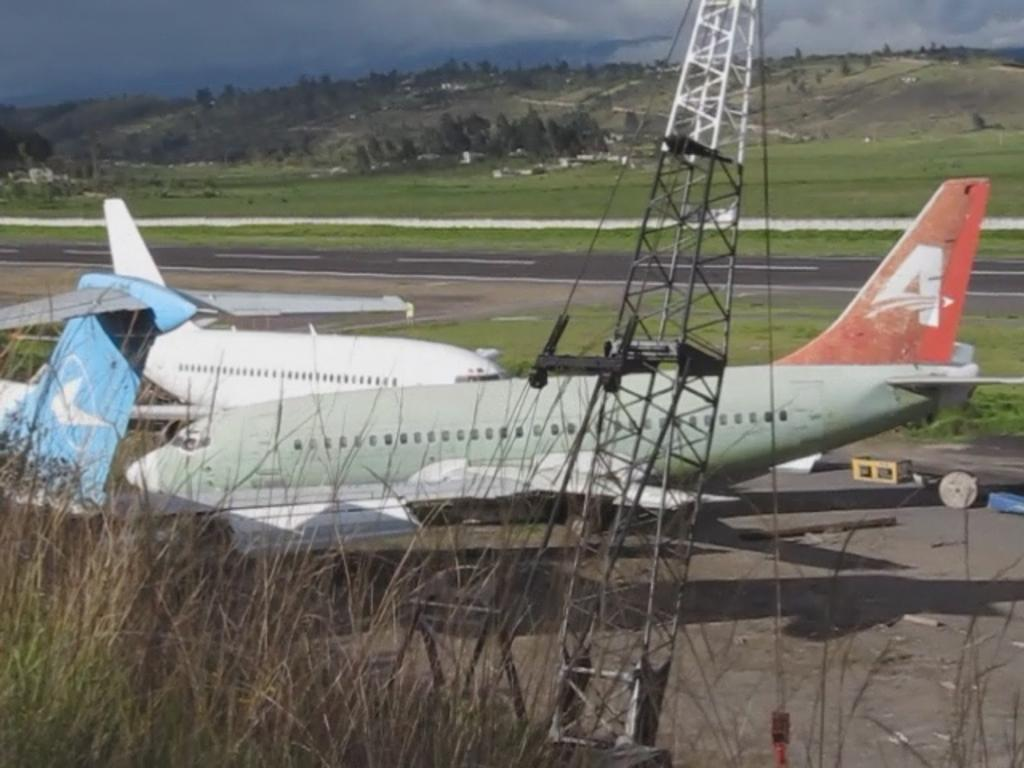<image>
Offer a succinct explanation of the picture presented. Two planes sit on a runway, one of which has an A on the tail. 